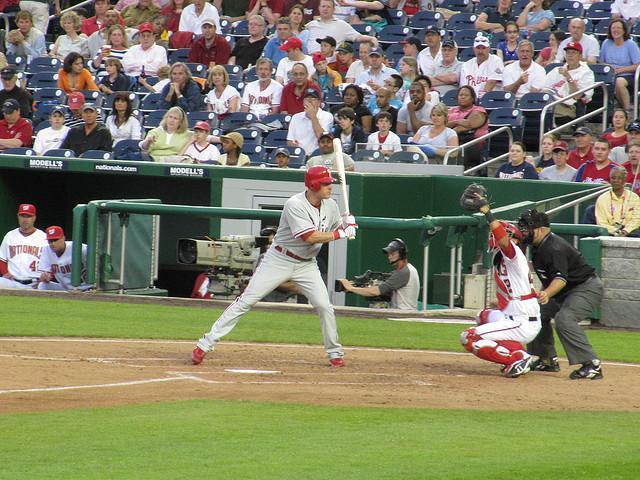How many people are there?
Give a very brief answer. 8. 